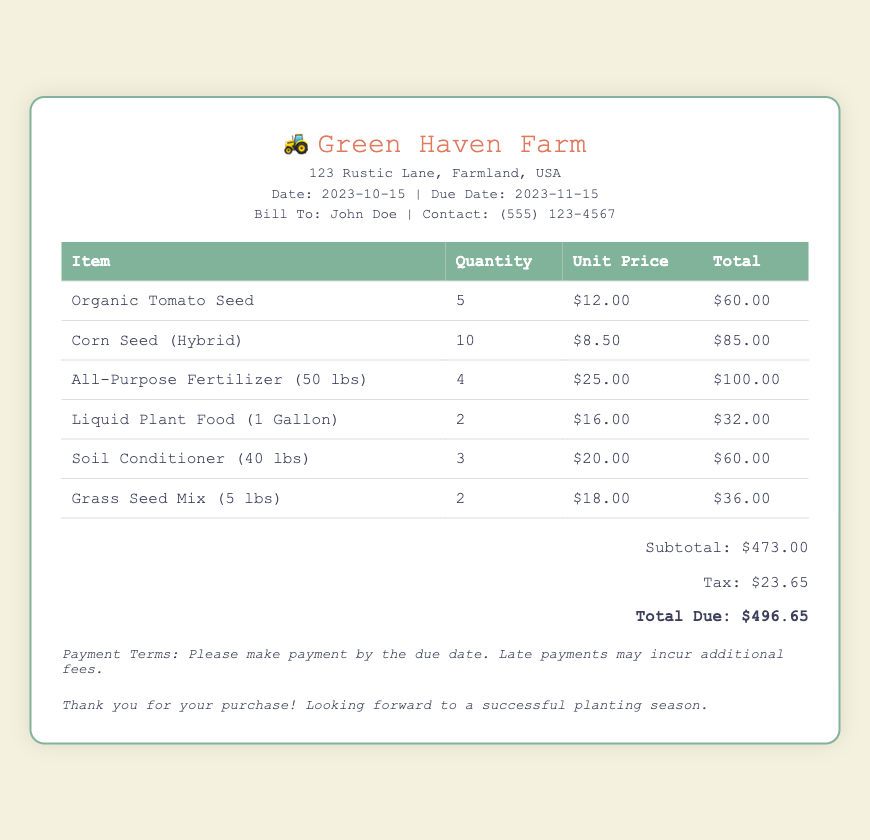What is the name of the farm? The name of the farm is displayed prominently at the top of the document.
Answer: Green Haven Farm What is the total due amount? The total amount due is calculated at the bottom of the bill summary.
Answer: $496.65 How many units of Corn Seed (Hybrid) were purchased? The quantity of each item purchased is listed in the table under the Quantity column.
Answer: 10 What is the unit price of Organic Tomato Seed? The unit price is shown next to each item in the table under the Unit Price column.
Answer: $12.00 What is the date of the bill? The date the bill was issued is mentioned in the header of the document.
Answer: 2023-10-15 What is the tax amount listed in the bill? The tax amount is provided in the summary section of the document.
Answer: $23.65 How many items are listed in the bill? The number of items in the bill can be determined by counting the rows in the purchase table.
Answer: 6 What is the payment term mentioned in the document? The payment terms are stated towards the bottom of the bill.
Answer: Please make payment by the due date What type of fertilizer is listed in the purchases? The type of fertilizer is specified in the item description in the table.
Answer: All-Purpose Fertilizer (50 lbs) 